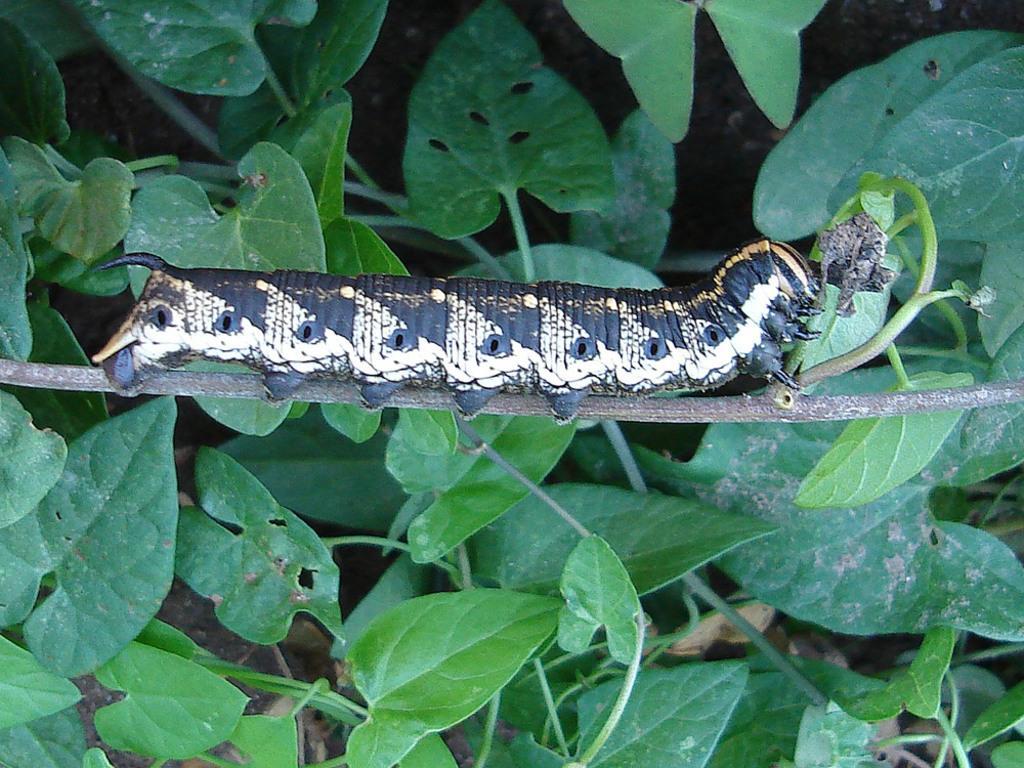In one or two sentences, can you explain what this image depicts? In this picture we can see insect on branch, green leaves and stems. 